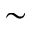Convert formula to latex. <formula><loc_0><loc_0><loc_500><loc_500>\sim</formula> 